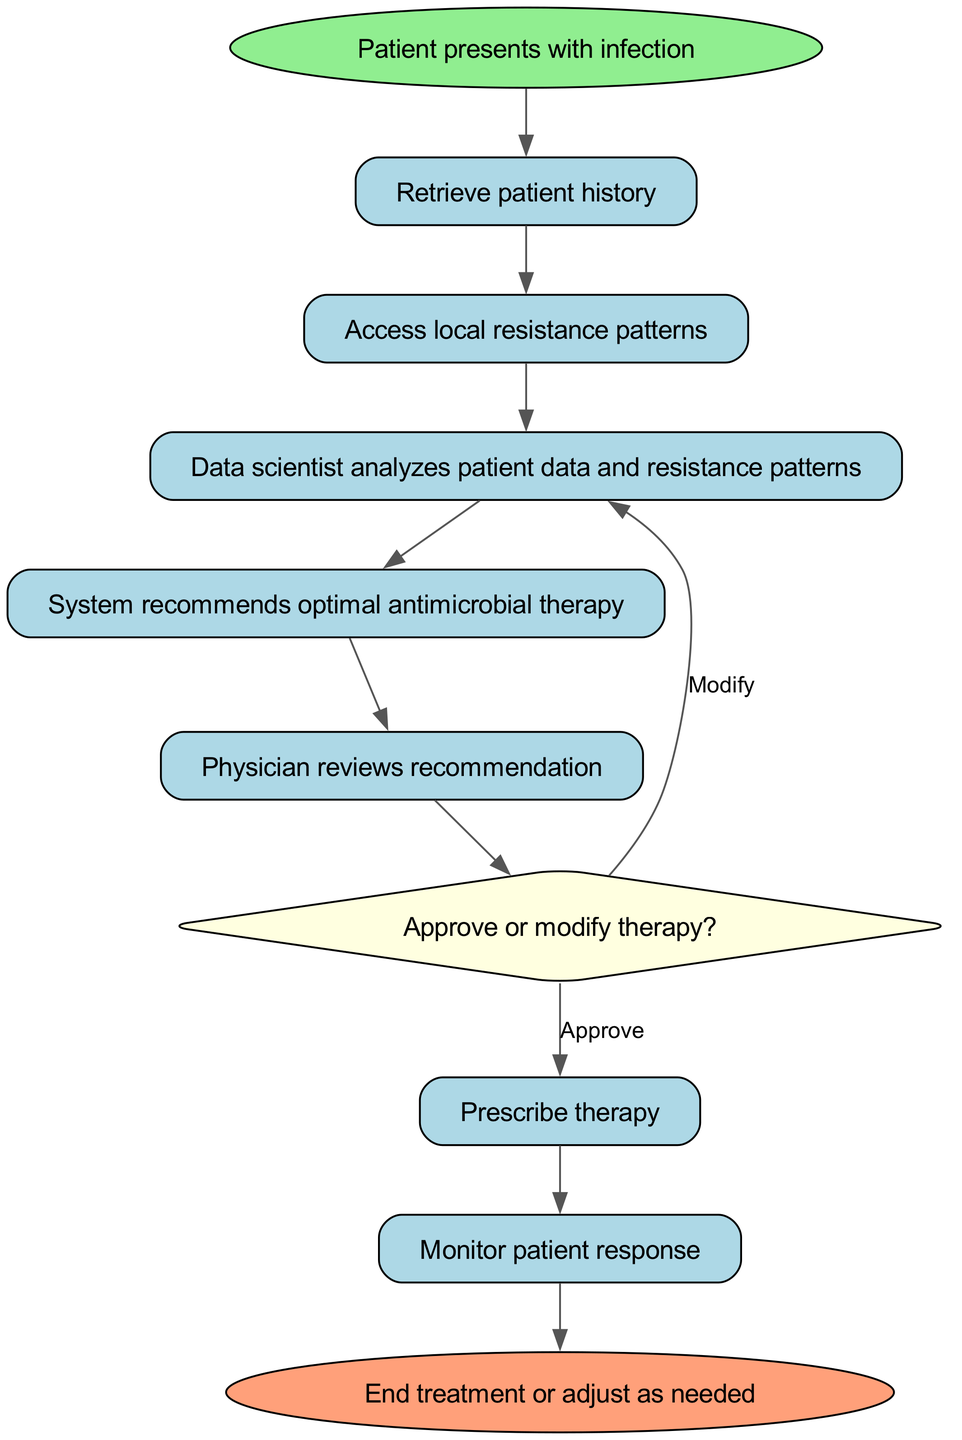What is the first step when a patient presents with infection? The diagram indicates that the first step after a patient presents with infection is to "Retrieve patient history". This is represented as the first node following the start node.
Answer: Retrieve patient history How many total nodes are in the flowchart? By counting the nodes listed in the provided data, there are ten distinct nodes that are part of the flowchart.
Answer: 10 What does the physician do after reviewing the therapy recommendation? In the flowchart, after the physician reviews the recommendation, the next step is a decision-making process, leading to "Approve or modify therapy?". This is directly connected to the physician review node.
Answer: Approve or modify therapy? What happens if the physician decides to modify therapy? According to the flowchart, if the physician chooses to modify therapy, it loops back to the "Data scientist analyzes patient data and resistance patterns" node. This indicates a re-evaluation of the initial analysis.
Answer: Data scientist analyzes patient data and resistance patterns What color represents the decision node in the diagram? The decision node, which is marked as "Approve or modify therapy?", is represented in the flowchart with a light yellow color, distinguishing it from other nodes.
Answer: Light yellow What is the final step in the treatment process? The last node before the flowchart ends is labeled "End treatment or adjust as needed", indicating that this is the conclusion of the treatment pathway shown in the diagram.
Answer: End treatment or adjust as needed What action follows after prescribing therapy? After the action to "Prescribe therapy", the next step in the flowchart is "Monitor patient response". This shows that monitoring comes directly after prescribing.
Answer: Monitor patient response What does the flowchart signify about local resistance patterns? In the flowchart, "Access local resistance patterns" is a crucial step that follows retrieving patient history, emphasizing its importance in the decision-making process for therapy selection.
Answer: Access local resistance patterns What type of node is the "decision" in the diagram? The "decision" node is shaped like a diamond, which is a common representation for decisions in flowcharts, signaling a point where a choice must be made.
Answer: Diamond 